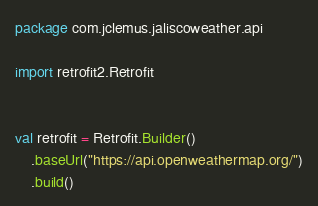Convert code to text. <code><loc_0><loc_0><loc_500><loc_500><_Kotlin_>package com.jclemus.jaliscoweather.api

import retrofit2.Retrofit


val retrofit = Retrofit.Builder()
    .baseUrl("https://api.openweathermap.org/")
    .build()</code> 